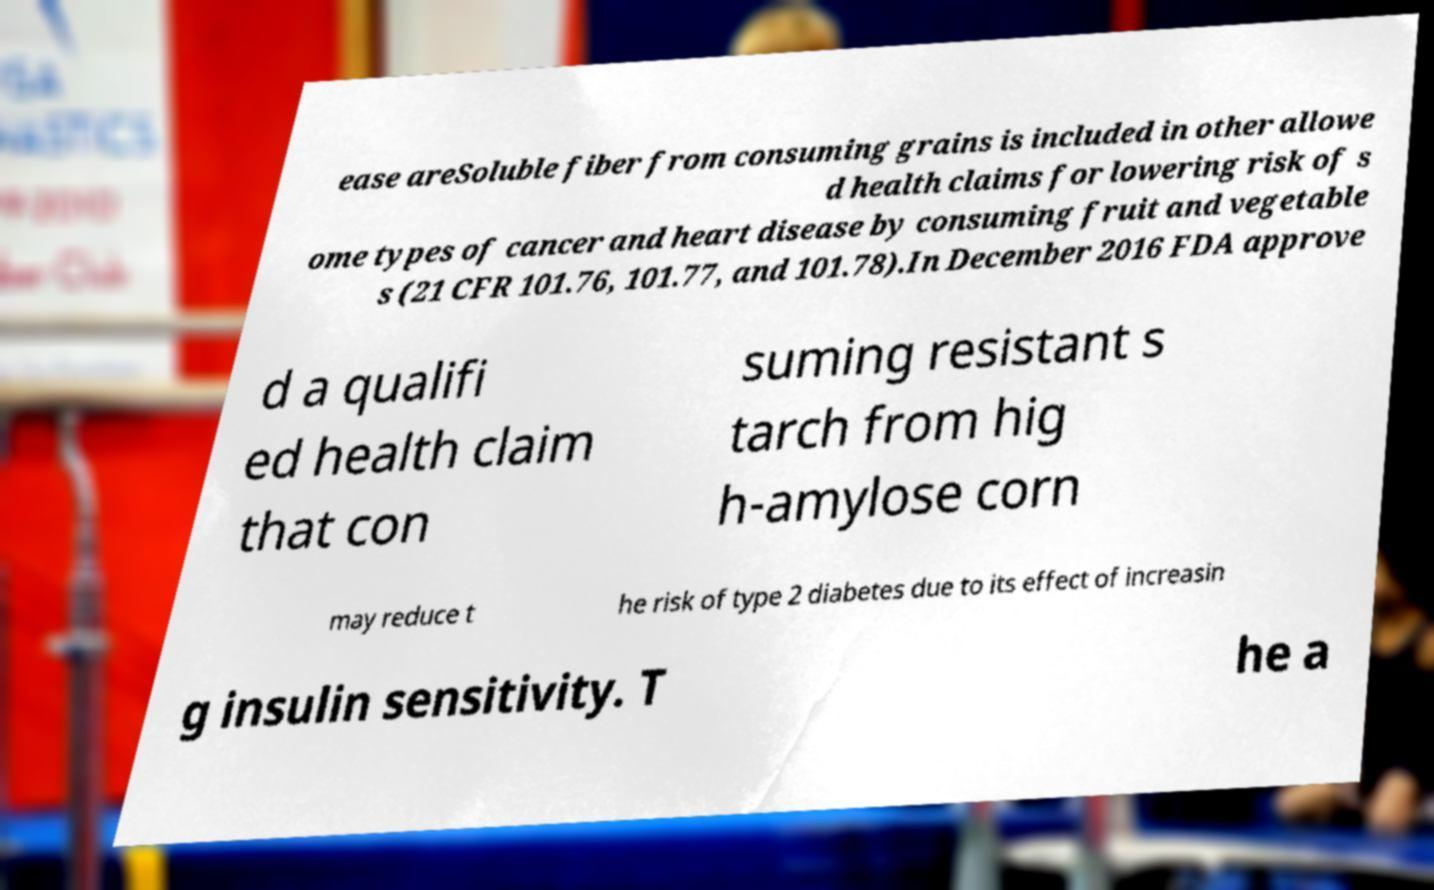Could you extract and type out the text from this image? ease areSoluble fiber from consuming grains is included in other allowe d health claims for lowering risk of s ome types of cancer and heart disease by consuming fruit and vegetable s (21 CFR 101.76, 101.77, and 101.78).In December 2016 FDA approve d a qualifi ed health claim that con suming resistant s tarch from hig h-amylose corn may reduce t he risk of type 2 diabetes due to its effect of increasin g insulin sensitivity. T he a 